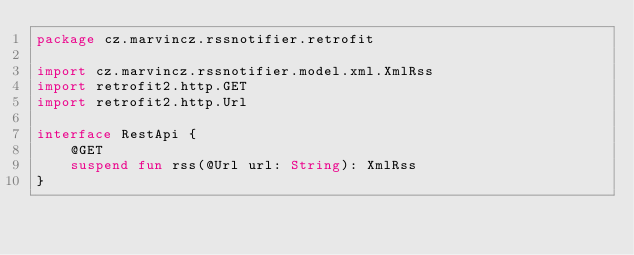Convert code to text. <code><loc_0><loc_0><loc_500><loc_500><_Kotlin_>package cz.marvincz.rssnotifier.retrofit

import cz.marvincz.rssnotifier.model.xml.XmlRss
import retrofit2.http.GET
import retrofit2.http.Url

interface RestApi {
    @GET
    suspend fun rss(@Url url: String): XmlRss
}
</code> 